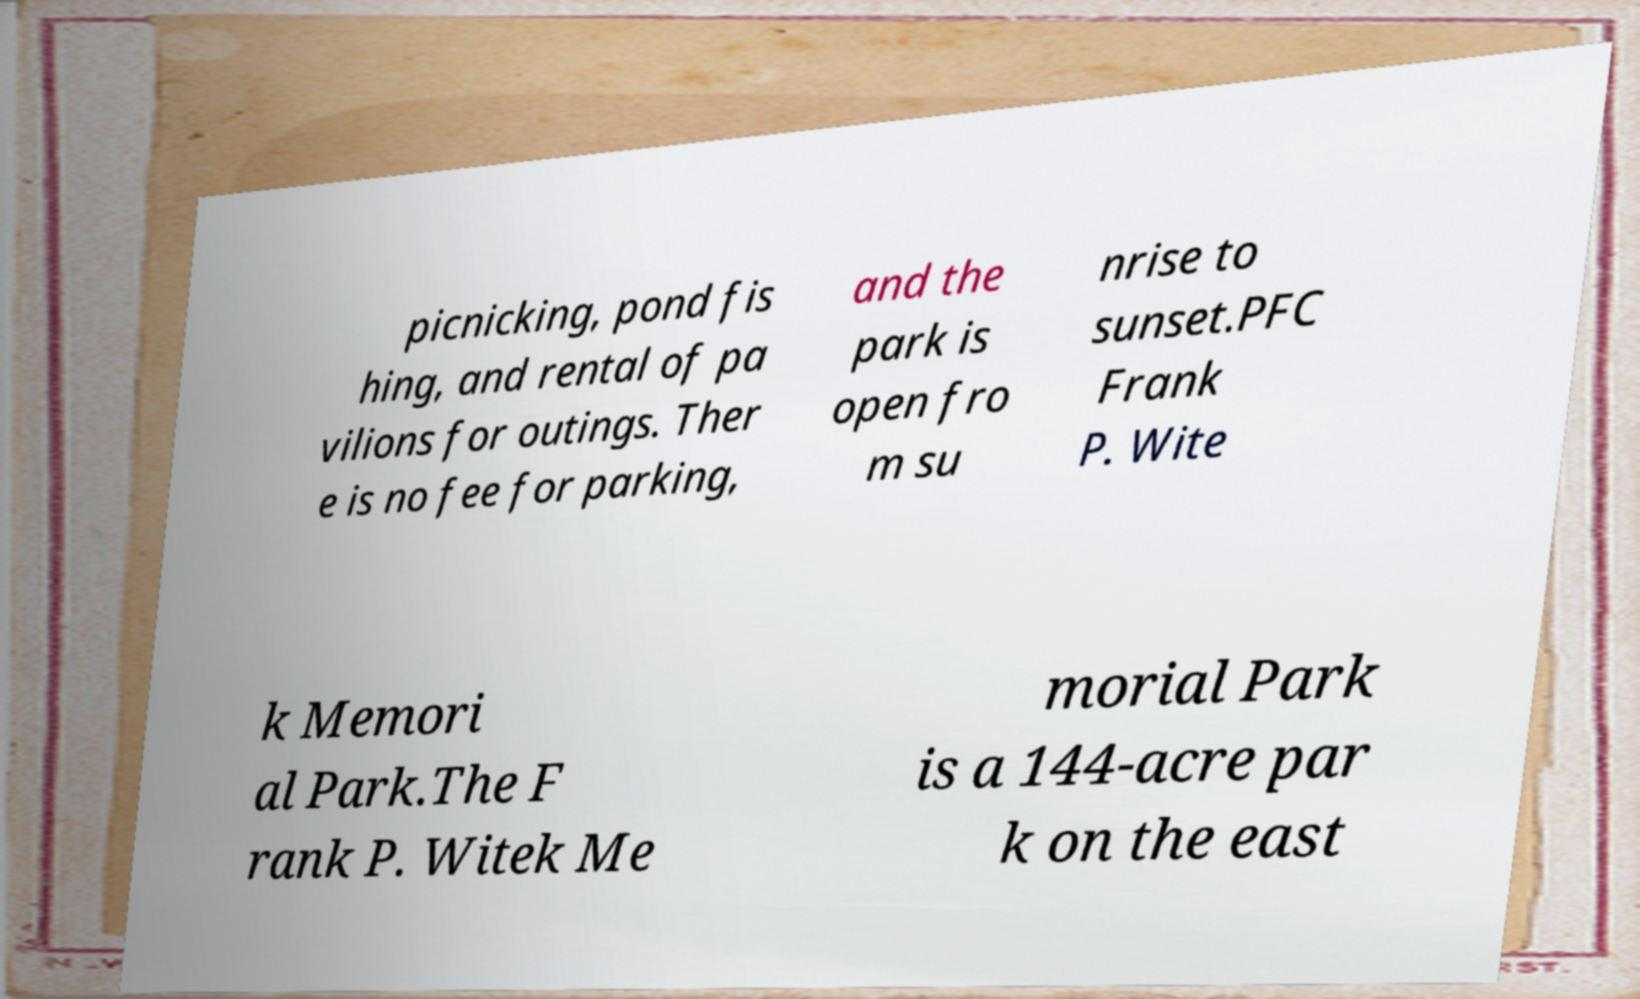Please read and relay the text visible in this image. What does it say? picnicking, pond fis hing, and rental of pa vilions for outings. Ther e is no fee for parking, and the park is open fro m su nrise to sunset.PFC Frank P. Wite k Memori al Park.The F rank P. Witek Me morial Park is a 144-acre par k on the east 